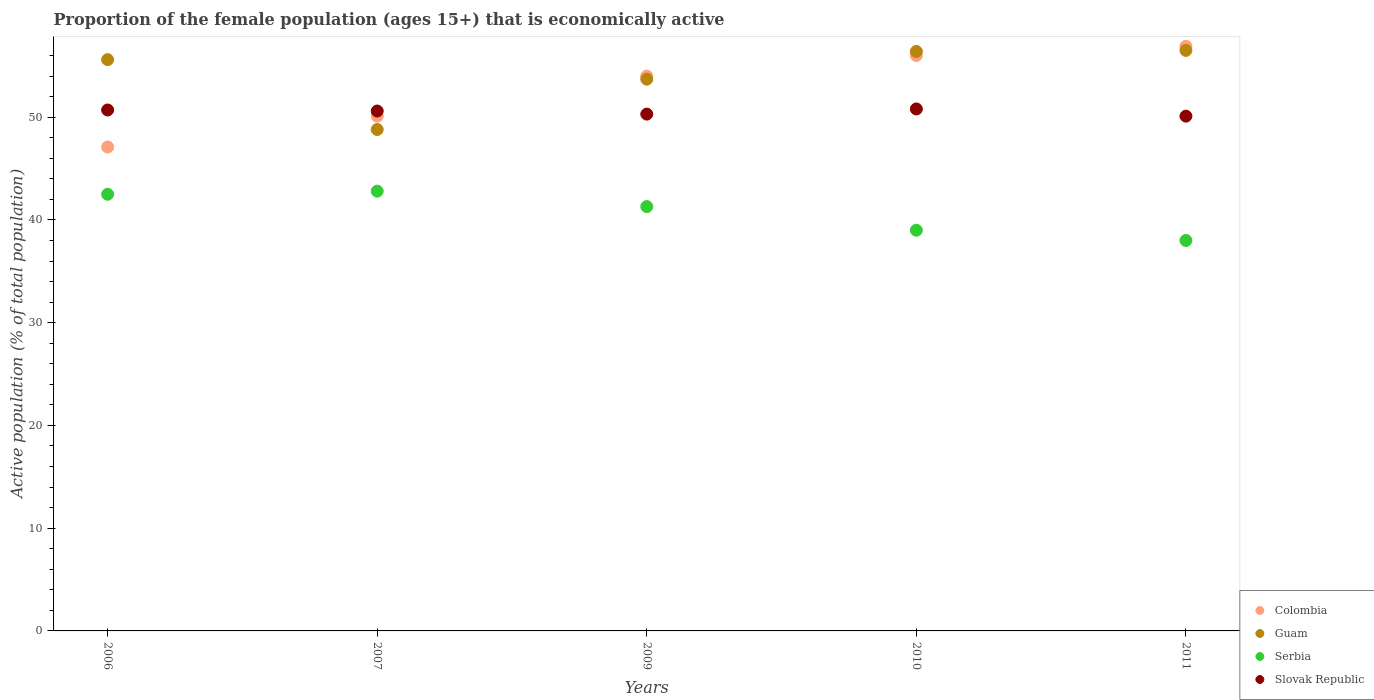What is the proportion of the female population that is economically active in Serbia in 2006?
Provide a succinct answer. 42.5. Across all years, what is the maximum proportion of the female population that is economically active in Guam?
Provide a succinct answer. 56.5. Across all years, what is the minimum proportion of the female population that is economically active in Colombia?
Ensure brevity in your answer.  47.1. In which year was the proportion of the female population that is economically active in Colombia maximum?
Your response must be concise. 2011. What is the total proportion of the female population that is economically active in Colombia in the graph?
Offer a very short reply. 264.1. What is the difference between the proportion of the female population that is economically active in Slovak Republic in 2006 and that in 2010?
Provide a succinct answer. -0.1. What is the difference between the proportion of the female population that is economically active in Slovak Republic in 2009 and the proportion of the female population that is economically active in Guam in 2010?
Your response must be concise. -6.1. What is the average proportion of the female population that is economically active in Colombia per year?
Your answer should be compact. 52.82. In the year 2009, what is the difference between the proportion of the female population that is economically active in Guam and proportion of the female population that is economically active in Colombia?
Give a very brief answer. -0.3. What is the ratio of the proportion of the female population that is economically active in Colombia in 2009 to that in 2010?
Ensure brevity in your answer.  0.96. Is the proportion of the female population that is economically active in Serbia in 2010 less than that in 2011?
Provide a short and direct response. No. Is the difference between the proportion of the female population that is economically active in Guam in 2006 and 2010 greater than the difference between the proportion of the female population that is economically active in Colombia in 2006 and 2010?
Offer a very short reply. Yes. What is the difference between the highest and the second highest proportion of the female population that is economically active in Serbia?
Offer a terse response. 0.3. What is the difference between the highest and the lowest proportion of the female population that is economically active in Guam?
Offer a very short reply. 7.7. Is the sum of the proportion of the female population that is economically active in Guam in 2006 and 2007 greater than the maximum proportion of the female population that is economically active in Colombia across all years?
Offer a terse response. Yes. Is the proportion of the female population that is economically active in Serbia strictly greater than the proportion of the female population that is economically active in Guam over the years?
Provide a succinct answer. No. Are the values on the major ticks of Y-axis written in scientific E-notation?
Give a very brief answer. No. Does the graph contain grids?
Your answer should be very brief. No. Where does the legend appear in the graph?
Make the answer very short. Bottom right. How are the legend labels stacked?
Provide a succinct answer. Vertical. What is the title of the graph?
Offer a very short reply. Proportion of the female population (ages 15+) that is economically active. What is the label or title of the Y-axis?
Your answer should be very brief. Active population (% of total population). What is the Active population (% of total population) in Colombia in 2006?
Offer a very short reply. 47.1. What is the Active population (% of total population) of Guam in 2006?
Make the answer very short. 55.6. What is the Active population (% of total population) of Serbia in 2006?
Give a very brief answer. 42.5. What is the Active population (% of total population) of Slovak Republic in 2006?
Provide a succinct answer. 50.7. What is the Active population (% of total population) in Colombia in 2007?
Your answer should be compact. 50.1. What is the Active population (% of total population) in Guam in 2007?
Keep it short and to the point. 48.8. What is the Active population (% of total population) of Serbia in 2007?
Keep it short and to the point. 42.8. What is the Active population (% of total population) in Slovak Republic in 2007?
Make the answer very short. 50.6. What is the Active population (% of total population) of Colombia in 2009?
Your answer should be very brief. 54. What is the Active population (% of total population) in Guam in 2009?
Your response must be concise. 53.7. What is the Active population (% of total population) in Serbia in 2009?
Offer a terse response. 41.3. What is the Active population (% of total population) of Slovak Republic in 2009?
Make the answer very short. 50.3. What is the Active population (% of total population) in Colombia in 2010?
Your response must be concise. 56. What is the Active population (% of total population) of Guam in 2010?
Offer a very short reply. 56.4. What is the Active population (% of total population) in Serbia in 2010?
Your response must be concise. 39. What is the Active population (% of total population) of Slovak Republic in 2010?
Your answer should be very brief. 50.8. What is the Active population (% of total population) of Colombia in 2011?
Offer a terse response. 56.9. What is the Active population (% of total population) in Guam in 2011?
Offer a very short reply. 56.5. What is the Active population (% of total population) of Serbia in 2011?
Offer a very short reply. 38. What is the Active population (% of total population) in Slovak Republic in 2011?
Make the answer very short. 50.1. Across all years, what is the maximum Active population (% of total population) of Colombia?
Your answer should be compact. 56.9. Across all years, what is the maximum Active population (% of total population) in Guam?
Offer a very short reply. 56.5. Across all years, what is the maximum Active population (% of total population) in Serbia?
Make the answer very short. 42.8. Across all years, what is the maximum Active population (% of total population) of Slovak Republic?
Give a very brief answer. 50.8. Across all years, what is the minimum Active population (% of total population) of Colombia?
Your response must be concise. 47.1. Across all years, what is the minimum Active population (% of total population) in Guam?
Offer a very short reply. 48.8. Across all years, what is the minimum Active population (% of total population) of Serbia?
Your answer should be very brief. 38. Across all years, what is the minimum Active population (% of total population) of Slovak Republic?
Offer a very short reply. 50.1. What is the total Active population (% of total population) in Colombia in the graph?
Your answer should be very brief. 264.1. What is the total Active population (% of total population) of Guam in the graph?
Make the answer very short. 271. What is the total Active population (% of total population) in Serbia in the graph?
Your answer should be compact. 203.6. What is the total Active population (% of total population) of Slovak Republic in the graph?
Give a very brief answer. 252.5. What is the difference between the Active population (% of total population) of Slovak Republic in 2006 and that in 2007?
Give a very brief answer. 0.1. What is the difference between the Active population (% of total population) of Colombia in 2006 and that in 2009?
Your answer should be compact. -6.9. What is the difference between the Active population (% of total population) in Serbia in 2006 and that in 2009?
Ensure brevity in your answer.  1.2. What is the difference between the Active population (% of total population) in Slovak Republic in 2006 and that in 2009?
Ensure brevity in your answer.  0.4. What is the difference between the Active population (% of total population) in Colombia in 2006 and that in 2010?
Your answer should be compact. -8.9. What is the difference between the Active population (% of total population) in Slovak Republic in 2006 and that in 2010?
Your response must be concise. -0.1. What is the difference between the Active population (% of total population) of Slovak Republic in 2006 and that in 2011?
Provide a succinct answer. 0.6. What is the difference between the Active population (% of total population) in Colombia in 2007 and that in 2009?
Give a very brief answer. -3.9. What is the difference between the Active population (% of total population) in Guam in 2007 and that in 2009?
Your answer should be very brief. -4.9. What is the difference between the Active population (% of total population) in Colombia in 2007 and that in 2010?
Your answer should be very brief. -5.9. What is the difference between the Active population (% of total population) in Serbia in 2007 and that in 2010?
Offer a very short reply. 3.8. What is the difference between the Active population (% of total population) in Guam in 2009 and that in 2010?
Provide a short and direct response. -2.7. What is the difference between the Active population (% of total population) of Serbia in 2009 and that in 2010?
Keep it short and to the point. 2.3. What is the difference between the Active population (% of total population) of Slovak Republic in 2009 and that in 2010?
Provide a short and direct response. -0.5. What is the difference between the Active population (% of total population) of Guam in 2010 and that in 2011?
Your response must be concise. -0.1. What is the difference between the Active population (% of total population) of Serbia in 2010 and that in 2011?
Keep it short and to the point. 1. What is the difference between the Active population (% of total population) of Slovak Republic in 2010 and that in 2011?
Ensure brevity in your answer.  0.7. What is the difference between the Active population (% of total population) of Colombia in 2006 and the Active population (% of total population) of Guam in 2007?
Your response must be concise. -1.7. What is the difference between the Active population (% of total population) in Colombia in 2006 and the Active population (% of total population) in Serbia in 2007?
Ensure brevity in your answer.  4.3. What is the difference between the Active population (% of total population) of Colombia in 2006 and the Active population (% of total population) of Slovak Republic in 2007?
Give a very brief answer. -3.5. What is the difference between the Active population (% of total population) in Guam in 2006 and the Active population (% of total population) in Serbia in 2007?
Make the answer very short. 12.8. What is the difference between the Active population (% of total population) in Guam in 2006 and the Active population (% of total population) in Slovak Republic in 2007?
Ensure brevity in your answer.  5. What is the difference between the Active population (% of total population) in Serbia in 2006 and the Active population (% of total population) in Slovak Republic in 2007?
Give a very brief answer. -8.1. What is the difference between the Active population (% of total population) of Colombia in 2006 and the Active population (% of total population) of Guam in 2009?
Provide a short and direct response. -6.6. What is the difference between the Active population (% of total population) in Colombia in 2006 and the Active population (% of total population) in Serbia in 2009?
Your response must be concise. 5.8. What is the difference between the Active population (% of total population) in Colombia in 2006 and the Active population (% of total population) in Slovak Republic in 2009?
Ensure brevity in your answer.  -3.2. What is the difference between the Active population (% of total population) in Guam in 2006 and the Active population (% of total population) in Slovak Republic in 2009?
Provide a short and direct response. 5.3. What is the difference between the Active population (% of total population) in Colombia in 2006 and the Active population (% of total population) in Guam in 2010?
Offer a very short reply. -9.3. What is the difference between the Active population (% of total population) in Colombia in 2006 and the Active population (% of total population) in Slovak Republic in 2010?
Provide a succinct answer. -3.7. What is the difference between the Active population (% of total population) of Guam in 2006 and the Active population (% of total population) of Slovak Republic in 2010?
Give a very brief answer. 4.8. What is the difference between the Active population (% of total population) in Colombia in 2006 and the Active population (% of total population) in Guam in 2011?
Offer a terse response. -9.4. What is the difference between the Active population (% of total population) in Colombia in 2006 and the Active population (% of total population) in Slovak Republic in 2011?
Offer a terse response. -3. What is the difference between the Active population (% of total population) of Guam in 2006 and the Active population (% of total population) of Serbia in 2011?
Provide a succinct answer. 17.6. What is the difference between the Active population (% of total population) in Colombia in 2007 and the Active population (% of total population) in Serbia in 2009?
Keep it short and to the point. 8.8. What is the difference between the Active population (% of total population) in Colombia in 2007 and the Active population (% of total population) in Slovak Republic in 2009?
Make the answer very short. -0.2. What is the difference between the Active population (% of total population) in Guam in 2007 and the Active population (% of total population) in Slovak Republic in 2009?
Your response must be concise. -1.5. What is the difference between the Active population (% of total population) of Serbia in 2007 and the Active population (% of total population) of Slovak Republic in 2009?
Give a very brief answer. -7.5. What is the difference between the Active population (% of total population) in Colombia in 2007 and the Active population (% of total population) in Serbia in 2010?
Offer a terse response. 11.1. What is the difference between the Active population (% of total population) of Guam in 2007 and the Active population (% of total population) of Slovak Republic in 2010?
Make the answer very short. -2. What is the difference between the Active population (% of total population) of Serbia in 2007 and the Active population (% of total population) of Slovak Republic in 2010?
Your answer should be compact. -8. What is the difference between the Active population (% of total population) of Colombia in 2007 and the Active population (% of total population) of Slovak Republic in 2011?
Give a very brief answer. 0. What is the difference between the Active population (% of total population) in Guam in 2007 and the Active population (% of total population) in Slovak Republic in 2011?
Ensure brevity in your answer.  -1.3. What is the difference between the Active population (% of total population) in Serbia in 2007 and the Active population (% of total population) in Slovak Republic in 2011?
Your answer should be compact. -7.3. What is the difference between the Active population (% of total population) in Guam in 2009 and the Active population (% of total population) in Serbia in 2010?
Keep it short and to the point. 14.7. What is the difference between the Active population (% of total population) of Guam in 2009 and the Active population (% of total population) of Slovak Republic in 2010?
Ensure brevity in your answer.  2.9. What is the difference between the Active population (% of total population) in Colombia in 2009 and the Active population (% of total population) in Slovak Republic in 2011?
Make the answer very short. 3.9. What is the difference between the Active population (% of total population) in Guam in 2009 and the Active population (% of total population) in Slovak Republic in 2011?
Offer a terse response. 3.6. What is the difference between the Active population (% of total population) in Colombia in 2010 and the Active population (% of total population) in Guam in 2011?
Your answer should be very brief. -0.5. What is the difference between the Active population (% of total population) in Colombia in 2010 and the Active population (% of total population) in Serbia in 2011?
Provide a short and direct response. 18. What is the difference between the Active population (% of total population) in Guam in 2010 and the Active population (% of total population) in Serbia in 2011?
Your answer should be very brief. 18.4. What is the difference between the Active population (% of total population) of Serbia in 2010 and the Active population (% of total population) of Slovak Republic in 2011?
Ensure brevity in your answer.  -11.1. What is the average Active population (% of total population) in Colombia per year?
Offer a terse response. 52.82. What is the average Active population (% of total population) of Guam per year?
Provide a short and direct response. 54.2. What is the average Active population (% of total population) of Serbia per year?
Your response must be concise. 40.72. What is the average Active population (% of total population) in Slovak Republic per year?
Ensure brevity in your answer.  50.5. In the year 2006, what is the difference between the Active population (% of total population) of Colombia and Active population (% of total population) of Guam?
Make the answer very short. -8.5. In the year 2006, what is the difference between the Active population (% of total population) in Colombia and Active population (% of total population) in Serbia?
Keep it short and to the point. 4.6. In the year 2006, what is the difference between the Active population (% of total population) in Colombia and Active population (% of total population) in Slovak Republic?
Your answer should be very brief. -3.6. In the year 2007, what is the difference between the Active population (% of total population) in Colombia and Active population (% of total population) in Slovak Republic?
Your response must be concise. -0.5. In the year 2007, what is the difference between the Active population (% of total population) in Serbia and Active population (% of total population) in Slovak Republic?
Your answer should be compact. -7.8. In the year 2009, what is the difference between the Active population (% of total population) in Colombia and Active population (% of total population) in Serbia?
Provide a short and direct response. 12.7. In the year 2009, what is the difference between the Active population (% of total population) of Colombia and Active population (% of total population) of Slovak Republic?
Provide a short and direct response. 3.7. In the year 2009, what is the difference between the Active population (% of total population) of Guam and Active population (% of total population) of Serbia?
Your response must be concise. 12.4. In the year 2009, what is the difference between the Active population (% of total population) in Guam and Active population (% of total population) in Slovak Republic?
Give a very brief answer. 3.4. In the year 2010, what is the difference between the Active population (% of total population) of Colombia and Active population (% of total population) of Guam?
Offer a very short reply. -0.4. In the year 2010, what is the difference between the Active population (% of total population) of Colombia and Active population (% of total population) of Slovak Republic?
Give a very brief answer. 5.2. In the year 2010, what is the difference between the Active population (% of total population) of Guam and Active population (% of total population) of Slovak Republic?
Offer a very short reply. 5.6. In the year 2011, what is the difference between the Active population (% of total population) of Serbia and Active population (% of total population) of Slovak Republic?
Provide a succinct answer. -12.1. What is the ratio of the Active population (% of total population) in Colombia in 2006 to that in 2007?
Keep it short and to the point. 0.94. What is the ratio of the Active population (% of total population) in Guam in 2006 to that in 2007?
Provide a short and direct response. 1.14. What is the ratio of the Active population (% of total population) in Serbia in 2006 to that in 2007?
Provide a succinct answer. 0.99. What is the ratio of the Active population (% of total population) in Slovak Republic in 2006 to that in 2007?
Offer a terse response. 1. What is the ratio of the Active population (% of total population) of Colombia in 2006 to that in 2009?
Ensure brevity in your answer.  0.87. What is the ratio of the Active population (% of total population) in Guam in 2006 to that in 2009?
Give a very brief answer. 1.04. What is the ratio of the Active population (% of total population) in Serbia in 2006 to that in 2009?
Your answer should be compact. 1.03. What is the ratio of the Active population (% of total population) of Slovak Republic in 2006 to that in 2009?
Provide a short and direct response. 1.01. What is the ratio of the Active population (% of total population) in Colombia in 2006 to that in 2010?
Your response must be concise. 0.84. What is the ratio of the Active population (% of total population) in Guam in 2006 to that in 2010?
Your answer should be very brief. 0.99. What is the ratio of the Active population (% of total population) of Serbia in 2006 to that in 2010?
Give a very brief answer. 1.09. What is the ratio of the Active population (% of total population) in Slovak Republic in 2006 to that in 2010?
Provide a short and direct response. 1. What is the ratio of the Active population (% of total population) of Colombia in 2006 to that in 2011?
Make the answer very short. 0.83. What is the ratio of the Active population (% of total population) in Guam in 2006 to that in 2011?
Your answer should be very brief. 0.98. What is the ratio of the Active population (% of total population) of Serbia in 2006 to that in 2011?
Give a very brief answer. 1.12. What is the ratio of the Active population (% of total population) of Colombia in 2007 to that in 2009?
Ensure brevity in your answer.  0.93. What is the ratio of the Active population (% of total population) in Guam in 2007 to that in 2009?
Offer a terse response. 0.91. What is the ratio of the Active population (% of total population) in Serbia in 2007 to that in 2009?
Keep it short and to the point. 1.04. What is the ratio of the Active population (% of total population) in Colombia in 2007 to that in 2010?
Your answer should be very brief. 0.89. What is the ratio of the Active population (% of total population) in Guam in 2007 to that in 2010?
Provide a short and direct response. 0.87. What is the ratio of the Active population (% of total population) of Serbia in 2007 to that in 2010?
Provide a short and direct response. 1.1. What is the ratio of the Active population (% of total population) in Slovak Republic in 2007 to that in 2010?
Provide a succinct answer. 1. What is the ratio of the Active population (% of total population) in Colombia in 2007 to that in 2011?
Provide a succinct answer. 0.88. What is the ratio of the Active population (% of total population) of Guam in 2007 to that in 2011?
Offer a terse response. 0.86. What is the ratio of the Active population (% of total population) in Serbia in 2007 to that in 2011?
Provide a succinct answer. 1.13. What is the ratio of the Active population (% of total population) of Slovak Republic in 2007 to that in 2011?
Your answer should be compact. 1.01. What is the ratio of the Active population (% of total population) in Colombia in 2009 to that in 2010?
Keep it short and to the point. 0.96. What is the ratio of the Active population (% of total population) in Guam in 2009 to that in 2010?
Offer a terse response. 0.95. What is the ratio of the Active population (% of total population) in Serbia in 2009 to that in 2010?
Your response must be concise. 1.06. What is the ratio of the Active population (% of total population) in Slovak Republic in 2009 to that in 2010?
Your response must be concise. 0.99. What is the ratio of the Active population (% of total population) of Colombia in 2009 to that in 2011?
Offer a terse response. 0.95. What is the ratio of the Active population (% of total population) in Guam in 2009 to that in 2011?
Ensure brevity in your answer.  0.95. What is the ratio of the Active population (% of total population) of Serbia in 2009 to that in 2011?
Give a very brief answer. 1.09. What is the ratio of the Active population (% of total population) in Slovak Republic in 2009 to that in 2011?
Your answer should be compact. 1. What is the ratio of the Active population (% of total population) of Colombia in 2010 to that in 2011?
Your answer should be very brief. 0.98. What is the ratio of the Active population (% of total population) of Serbia in 2010 to that in 2011?
Ensure brevity in your answer.  1.03. What is the difference between the highest and the second highest Active population (% of total population) in Guam?
Offer a terse response. 0.1. What is the difference between the highest and the second highest Active population (% of total population) in Serbia?
Keep it short and to the point. 0.3. What is the difference between the highest and the second highest Active population (% of total population) in Slovak Republic?
Give a very brief answer. 0.1. What is the difference between the highest and the lowest Active population (% of total population) of Colombia?
Keep it short and to the point. 9.8. What is the difference between the highest and the lowest Active population (% of total population) of Guam?
Your answer should be compact. 7.7. 